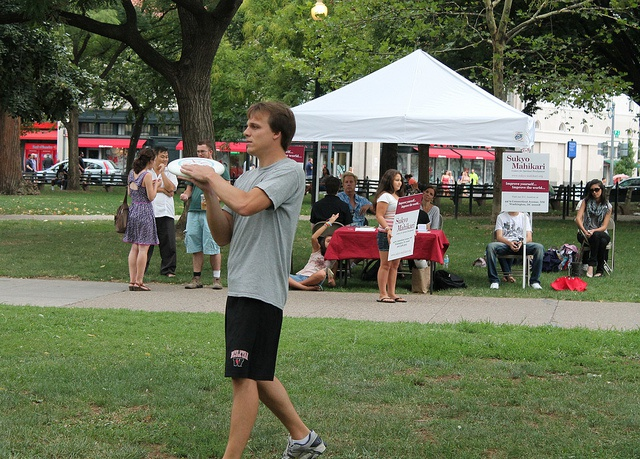Describe the objects in this image and their specific colors. I can see people in black, darkgray, and gray tones, people in black, gray, and tan tones, people in black, gray, and darkgray tones, people in black, lavender, gray, and darkgray tones, and people in black, brown, maroon, and lightgray tones in this image. 